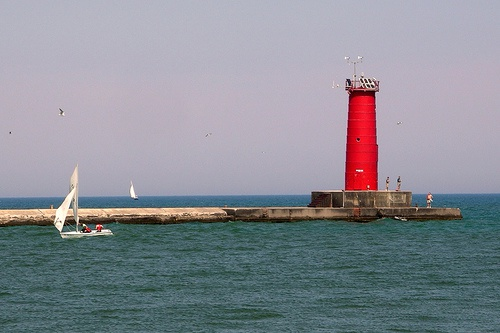Describe the objects in this image and their specific colors. I can see boat in darkgray, ivory, gray, and tan tones, boat in darkgray, black, maroon, and gray tones, people in darkgray, black, gray, maroon, and ivory tones, boat in darkgray, ivory, and gray tones, and people in darkgray, black, maroon, red, and gray tones in this image. 